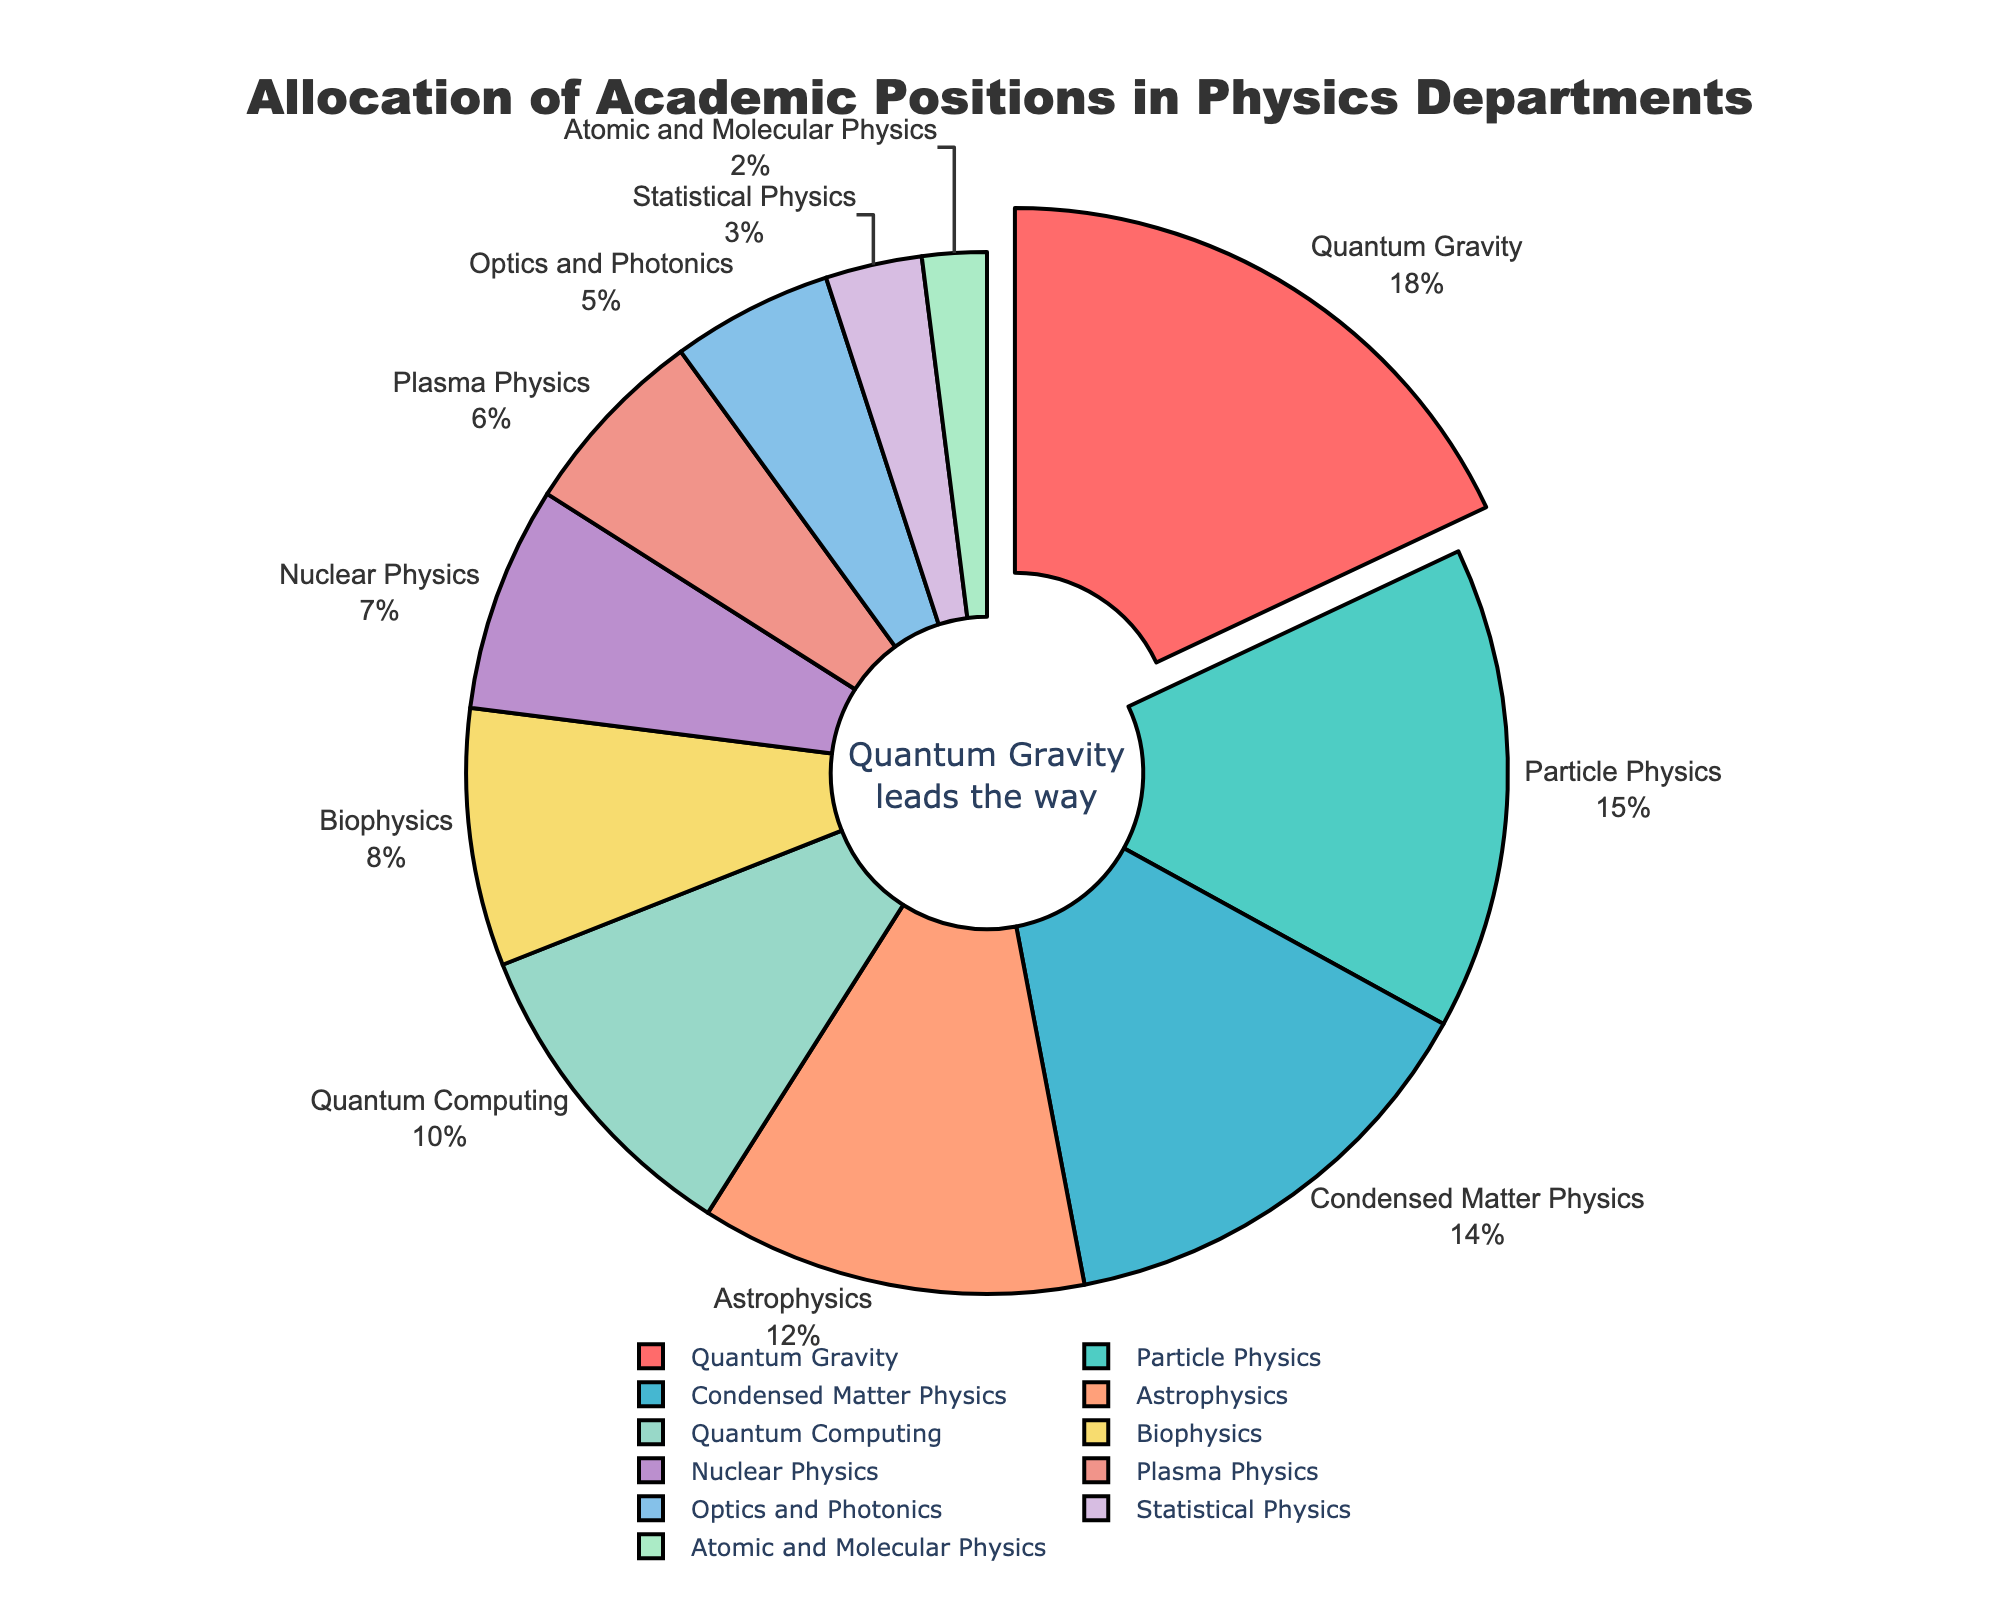Which specialization has the largest proportion of academic positions? The pie chart shows the allocation of academic positions by specialization, with a chunk labeled "Quantum Gravity" pulled out and highlighted. This visual emphasis indicates that Quantum Gravity has the largest proportion.
Answer: Quantum Gravity How do the percentages of Particle Physics and Condensed Matter Physics compare? By referring to the pie chart, you can see that Particle Physics has 15% of academic positions, while Condensed Matter Physics has 14%. Therefore, Particle Physics has a slightly larger share.
Answer: Particle Physics is larger What is the combined percentage of academic positions for Biophysics, Nuclear Physics, and Plasma Physics? Summing up the percentages from the pie chart: Biophysics (8%), Nuclear Physics (7%), and Plasma Physics (6%). So, 8 + 7 + 6 = 21%.
Answer: 21% Is the proportion of academic positions in Statistical Physics higher or lower than in Atomic and Molecular Physics? The pie chart indicates that Statistical Physics has 3% and Atomic and Molecular Physics has 2%, making Statistical Physics marginally higher.
Answer: Higher Which specialization has the smallest fraction of academic positions and what is its percentage? By identifying the smallest segment in the pie chart, it's clear that Atomic and Molecular Physics holds the smallest fraction with 2% of the academic positions.
Answer: Atomic and Molecular Physics with 2% What is the difference in academic position allocation between Quantum Computing and Optics and Photonics? Quantum Computing has 10% while Optics and Photonics have 5%. The difference is 10 - 5 = 5%.
Answer: 5% What percentage of academic positions is allocated to Quantum Gravity compared to the combined allocation for Biophysics and Plasma Physics? Quantum Gravity has 18%, Biophysics has 8%, and Plasma Physics has 6%. The combined percentage for Biophysics and Plasma Physics is 8 + 6 = 14%. So, Quantum Gravity's allocation of 18% is compared to 14%.
Answer: 18% vs 14% Which specialization, among those with double-digit percentages, has the smallest allocation? The specializations with double-digit percentages are Quantum Gravity (18%), Particle Physics (15%), Condensed Matter Physics (14%), Astrophysics (12%), and Quantum Computing (10%). Among these, Quantum Computing has the smallest allocation with 10%.
Answer: Quantum Computing How much greater is the proportion of academic positions for Quantum Gravity than that for Statistical Physics? Quantum Gravity has 18% and Statistical Physics has 3%. The difference is found by subtracting: 18% - 3% = 15%.
Answer: 15% How does the total percentage of positions for specializations with single-digit percentages compare to those with double-digit percentages? Summing the specializations with single-digit percentages: Biophysics (8%) + Nuclear Physics (7%) + Plasma Physics (6%) + Optics and Photonics (5%) + Statistical Physics (3%) + Atomic and Molecular Physics (2%) = 31%. Summing the double-digit percentages: Quantum Gravity (18%) + Particle Physics (15%) + Condensed Matter Physics (14%) + Astrophysics (12%) + Quantum Computing (10%) = 69%.
Answer: 31% vs 69% 